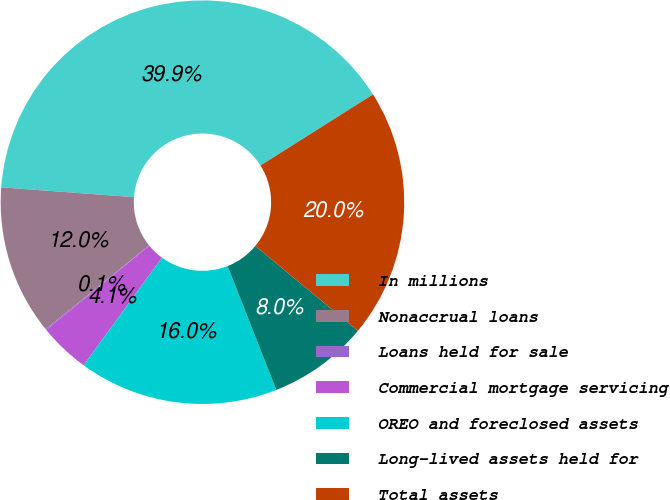Convert chart. <chart><loc_0><loc_0><loc_500><loc_500><pie_chart><fcel>In millions<fcel>Nonaccrual loans<fcel>Loans held for sale<fcel>Commercial mortgage servicing<fcel>OREO and foreclosed assets<fcel>Long-lived assets held for<fcel>Total assets<nl><fcel>39.86%<fcel>12.01%<fcel>0.08%<fcel>4.06%<fcel>15.99%<fcel>8.03%<fcel>19.97%<nl></chart> 